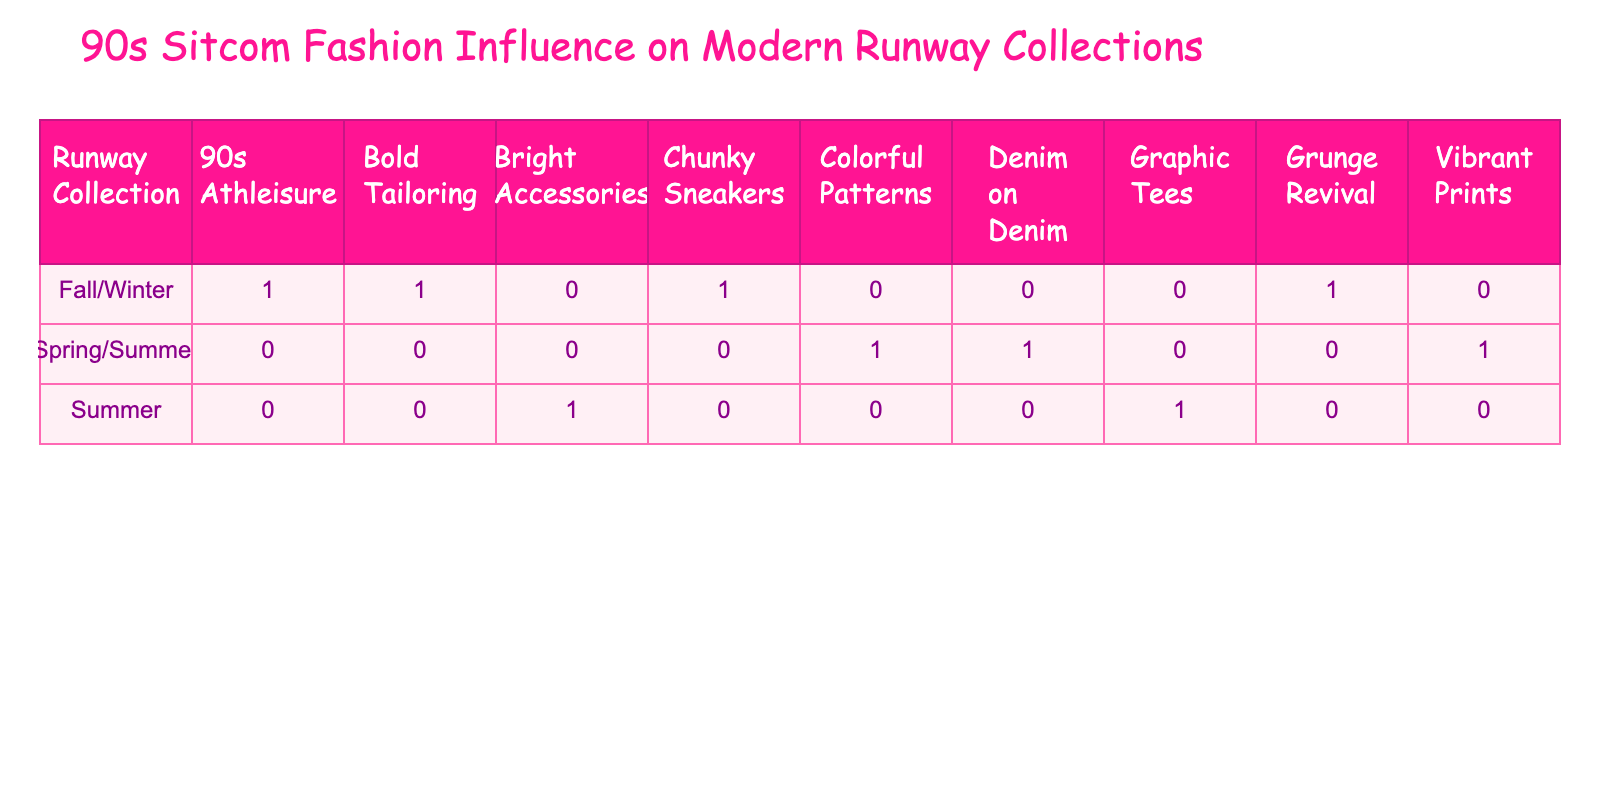What runway collection in 2015 was influenced by the Fresh Prince of Bel-Air? The table specifies that the 2015 Spring/Summer collection, designed by Marc Jacobs, was influenced by the Fresh Prince of Bel-Air.
Answer: 2015 Spring/Summer How many different influence types are represented in the table? By counting the unique influence types listed under the "Influence Type" column, we find that there are 7 different types: Colorful Patterns, Grunge Revival, Denim on Denim, Bold Tailoring, Graphic Tees, 90s Athleisure, and Vibrant Prints.
Answer: 7 Was there any runway collection influenced by the sitcom Friends? By examining the table, it is noted that the 2016 Fall/Winter collection, designed by Alexander Wang, and the 2022 Fall/Winter collection, reflecting Jennifer Aniston's style on Friends, are both influenced by Friends.
Answer: Yes Which influence type was most frequently represented across the years? Analyzing the "Influence Type" column shows that "Colorful Patterns" and "Vibrant Prints" appear once, while "Graphic Tees" shows up once. The others all appear once, making each type equally represented, with no preference in frequency.
Answer: All are equally represented In which years did the influence of The Fresh Prince of Bel-Air appear in runway collections? The data indicates that the influence of The Fresh Prince of Bel-Air appears in 2015 for the Colorful Patterns and 2020 for Athleisure. These are the only two occurrences listed in the table.
Answer: 2015 and 2020 What is the total number of runway collections influenced by sitcoms that feature vibrant colors? The collections influenced by vibrant colors are the 2015 Spring/Summer (Colorful Patterns), 2018 Fall/Winter (Bold Tailoring), 2021 Spring/Summer (Vibrant Prints), and 2023 Summer (Bright Accessories). Adding these gives a total of 4 runway collections.
Answer: 4 Did any collection from 2022 include a reference to a 90s sitcom? By checking the table, it can be seen that the 2022 Fall/Winter collection was influenced by Jennifer Aniston's style on Friends, confirming that a 90s sitcom reference is present.
Answer: Yes Which designer presented a collection with a Grunge Revival influence? From the table, it is clear that the 2016 Fall/Winter collection, designed by Alexander Wang, is associated with the Grunge Revival influence.
Answer: Alexander Wang 